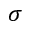<formula> <loc_0><loc_0><loc_500><loc_500>\sigma</formula> 